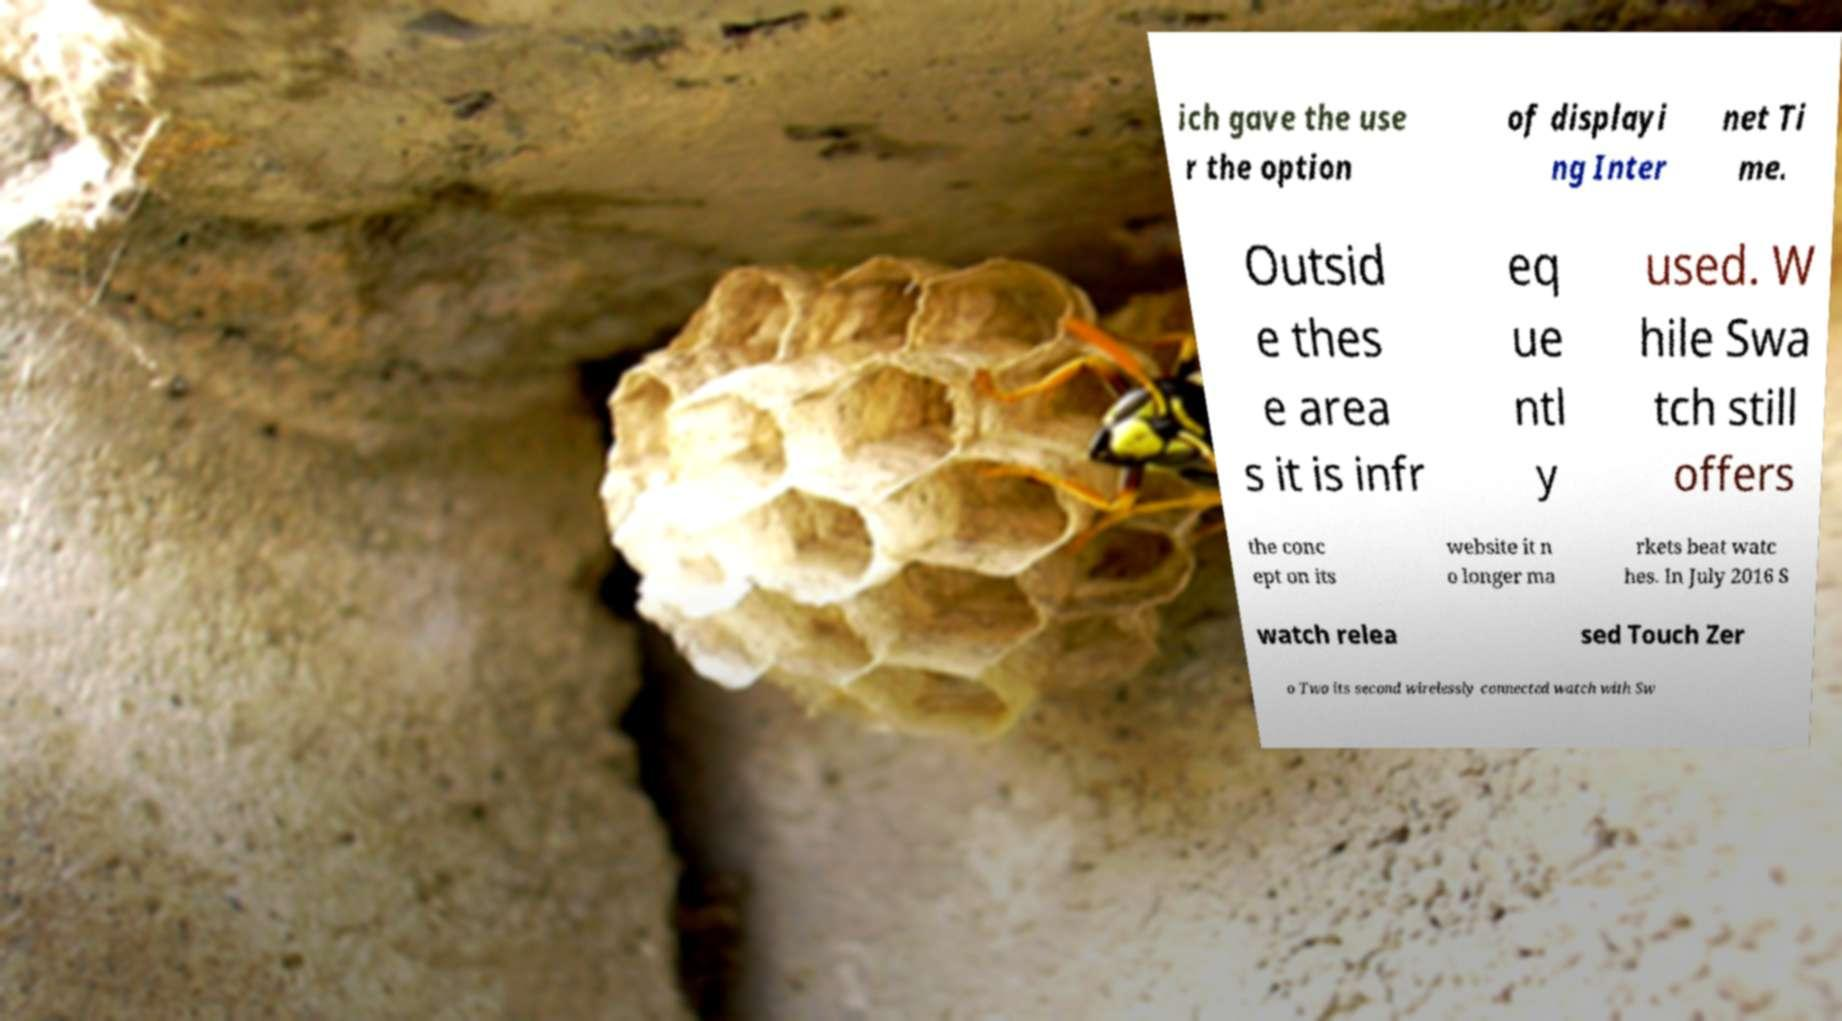Please identify and transcribe the text found in this image. ich gave the use r the option of displayi ng Inter net Ti me. Outsid e thes e area s it is infr eq ue ntl y used. W hile Swa tch still offers the conc ept on its website it n o longer ma rkets beat watc hes. In July 2016 S watch relea sed Touch Zer o Two its second wirelessly connected watch with Sw 